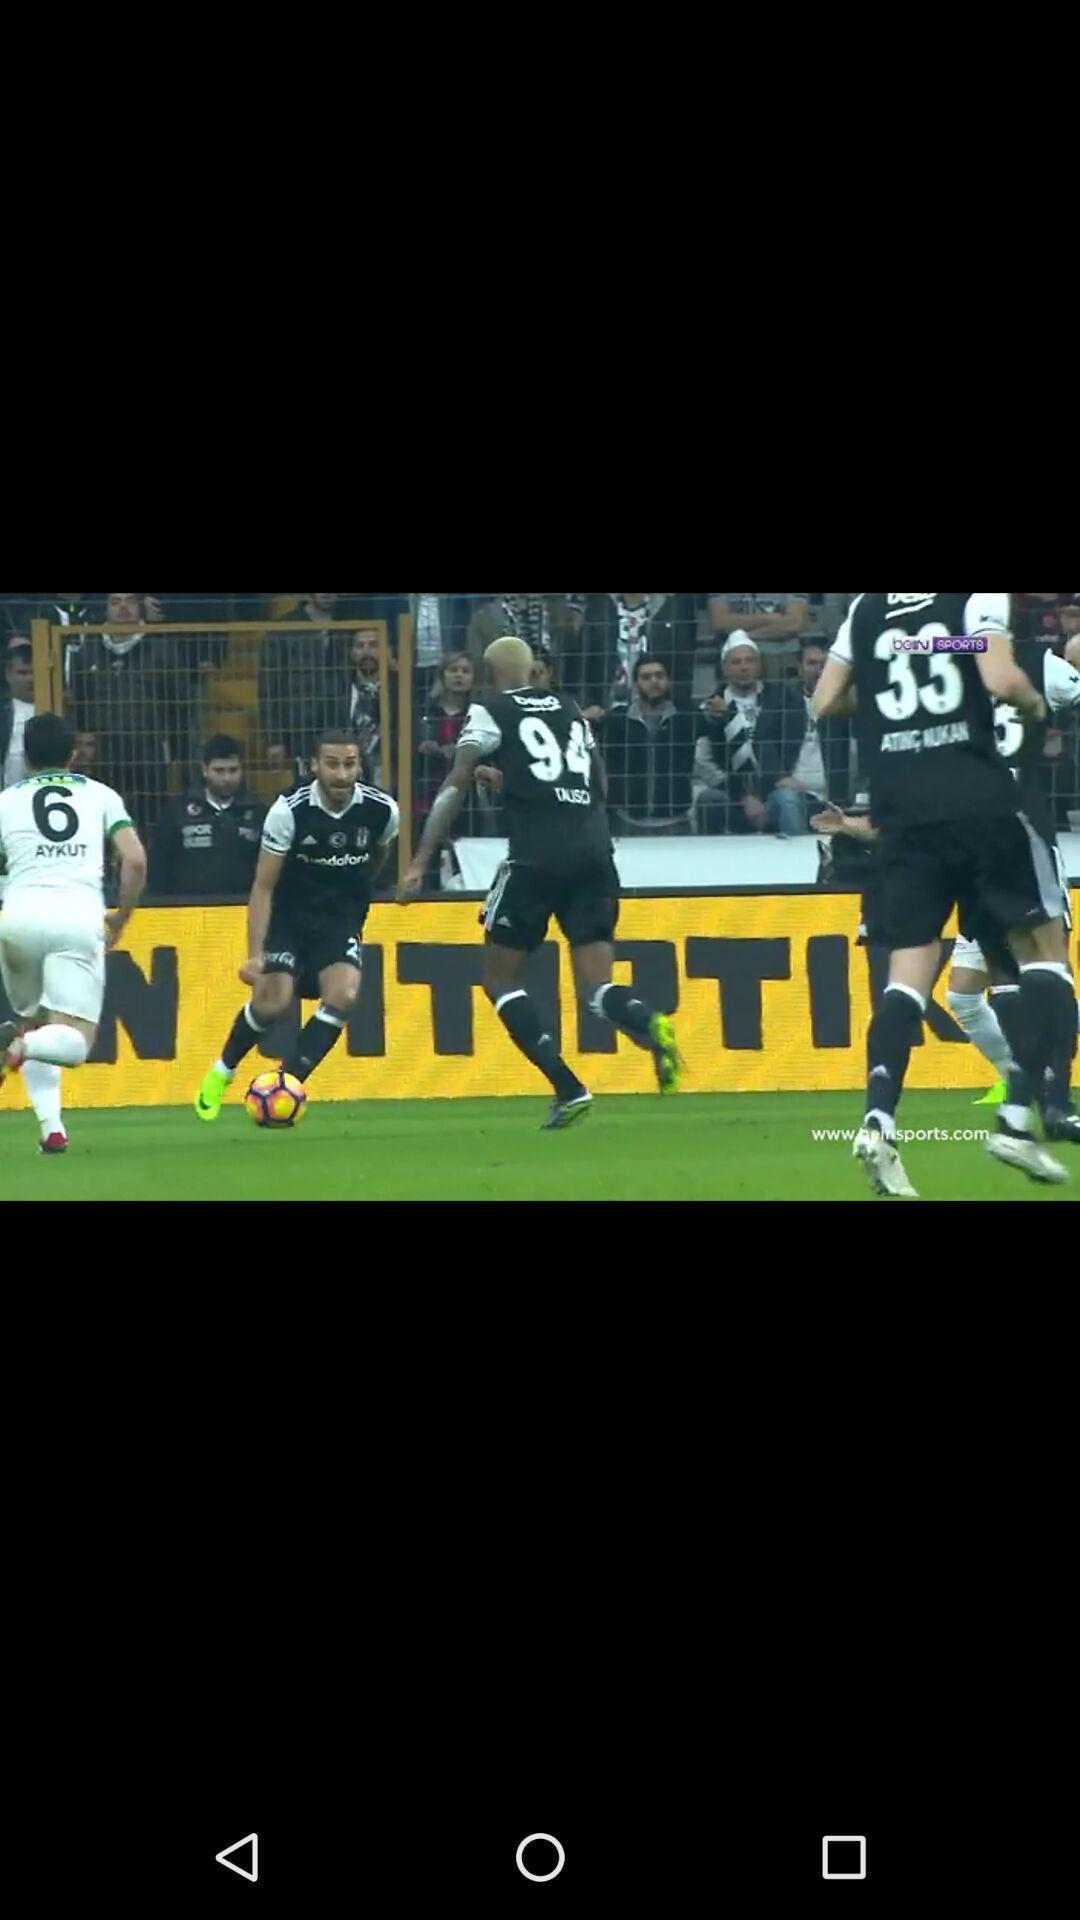Summarize the main components in this picture. Page displaying an image in the application. 